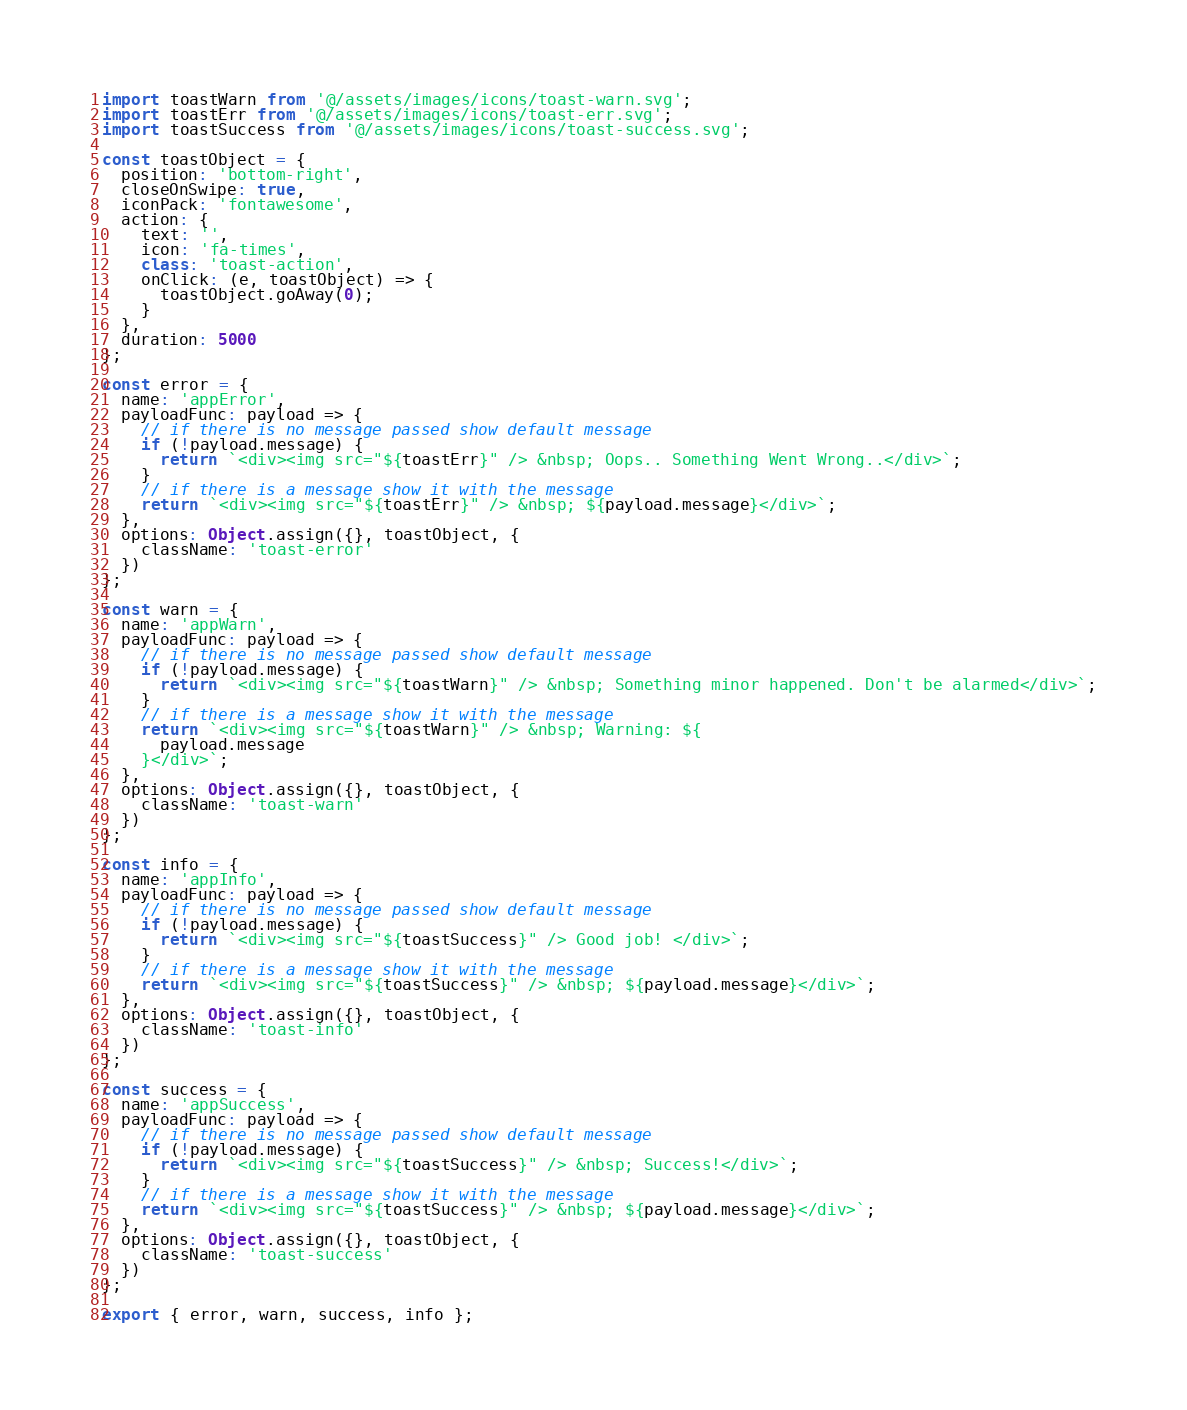Convert code to text. <code><loc_0><loc_0><loc_500><loc_500><_JavaScript_>import toastWarn from '@/assets/images/icons/toast-warn.svg';
import toastErr from '@/assets/images/icons/toast-err.svg';
import toastSuccess from '@/assets/images/icons/toast-success.svg';

const toastObject = {
  position: 'bottom-right',
  closeOnSwipe: true,
  iconPack: 'fontawesome',
  action: {
    text: '',
    icon: 'fa-times',
    class: 'toast-action',
    onClick: (e, toastObject) => {
      toastObject.goAway(0);
    }
  },
  duration: 5000
};

const error = {
  name: 'appError',
  payloadFunc: payload => {
    // if there is no message passed show default message
    if (!payload.message) {
      return `<div><img src="${toastErr}" /> &nbsp; Oops.. Something Went Wrong..</div>`;
    }
    // if there is a message show it with the message
    return `<div><img src="${toastErr}" /> &nbsp; ${payload.message}</div>`;
  },
  options: Object.assign({}, toastObject, {
    className: 'toast-error'
  })
};

const warn = {
  name: 'appWarn',
  payloadFunc: payload => {
    // if there is no message passed show default message
    if (!payload.message) {
      return `<div><img src="${toastWarn}" /> &nbsp; Something minor happened. Don't be alarmed</div>`;
    }
    // if there is a message show it with the message
    return `<div><img src="${toastWarn}" /> &nbsp; Warning: ${
      payload.message
    }</div>`;
  },
  options: Object.assign({}, toastObject, {
    className: 'toast-warn'
  })
};

const info = {
  name: 'appInfo',
  payloadFunc: payload => {
    // if there is no message passed show default message
    if (!payload.message) {
      return `<div><img src="${toastSuccess}" /> Good job! </div>`;
    }
    // if there is a message show it with the message
    return `<div><img src="${toastSuccess}" /> &nbsp; ${payload.message}</div>`;
  },
  options: Object.assign({}, toastObject, {
    className: 'toast-info'
  })
};

const success = {
  name: 'appSuccess',
  payloadFunc: payload => {
    // if there is no message passed show default message
    if (!payload.message) {
      return `<div><img src="${toastSuccess}" /> &nbsp; Success!</div>`;
    }
    // if there is a message show it with the message
    return `<div><img src="${toastSuccess}" /> &nbsp; ${payload.message}</div>`;
  },
  options: Object.assign({}, toastObject, {
    className: 'toast-success'
  })
};

export { error, warn, success, info };
</code> 